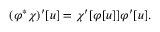<formula> <loc_0><loc_0><loc_500><loc_500>( \varphi ^ { * } \chi ) ^ { \prime } [ u ] = \chi ^ { \prime } [ \varphi [ u ] ] \varphi ^ { \prime } [ u ] .</formula> 